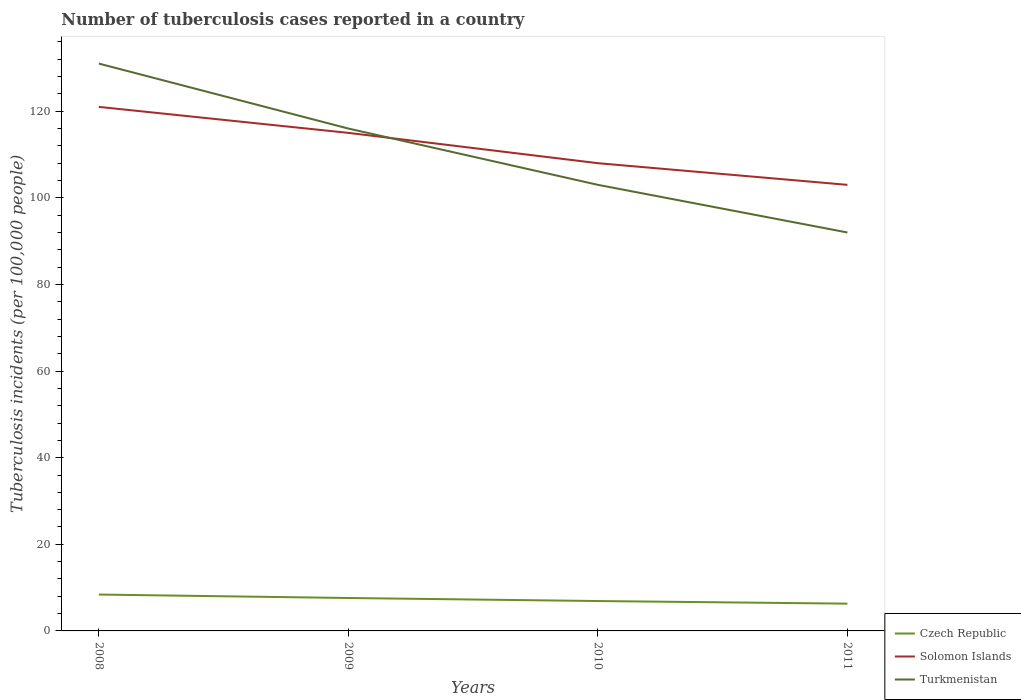How many different coloured lines are there?
Your answer should be very brief. 3. Does the line corresponding to Turkmenistan intersect with the line corresponding to Solomon Islands?
Ensure brevity in your answer.  Yes. Is the number of lines equal to the number of legend labels?
Keep it short and to the point. Yes. Across all years, what is the maximum number of tuberculosis cases reported in in Czech Republic?
Offer a very short reply. 6.3. What is the total number of tuberculosis cases reported in in Turkmenistan in the graph?
Your answer should be compact. 15. What is the difference between the highest and the second highest number of tuberculosis cases reported in in Solomon Islands?
Offer a very short reply. 18. What is the difference between the highest and the lowest number of tuberculosis cases reported in in Czech Republic?
Offer a terse response. 2. How many lines are there?
Give a very brief answer. 3. What is the difference between two consecutive major ticks on the Y-axis?
Offer a very short reply. 20. Are the values on the major ticks of Y-axis written in scientific E-notation?
Offer a terse response. No. Does the graph contain any zero values?
Give a very brief answer. No. Does the graph contain grids?
Provide a short and direct response. No. What is the title of the graph?
Keep it short and to the point. Number of tuberculosis cases reported in a country. What is the label or title of the X-axis?
Keep it short and to the point. Years. What is the label or title of the Y-axis?
Your response must be concise. Tuberculosis incidents (per 100,0 people). What is the Tuberculosis incidents (per 100,000 people) in Solomon Islands in 2008?
Give a very brief answer. 121. What is the Tuberculosis incidents (per 100,000 people) of Turkmenistan in 2008?
Your answer should be compact. 131. What is the Tuberculosis incidents (per 100,000 people) in Czech Republic in 2009?
Ensure brevity in your answer.  7.6. What is the Tuberculosis incidents (per 100,000 people) of Solomon Islands in 2009?
Your response must be concise. 115. What is the Tuberculosis incidents (per 100,000 people) in Turkmenistan in 2009?
Offer a very short reply. 116. What is the Tuberculosis incidents (per 100,000 people) of Czech Republic in 2010?
Your answer should be compact. 6.9. What is the Tuberculosis incidents (per 100,000 people) of Solomon Islands in 2010?
Offer a terse response. 108. What is the Tuberculosis incidents (per 100,000 people) in Turkmenistan in 2010?
Keep it short and to the point. 103. What is the Tuberculosis incidents (per 100,000 people) of Solomon Islands in 2011?
Make the answer very short. 103. What is the Tuberculosis incidents (per 100,000 people) of Turkmenistan in 2011?
Your answer should be compact. 92. Across all years, what is the maximum Tuberculosis incidents (per 100,000 people) in Solomon Islands?
Your answer should be compact. 121. Across all years, what is the maximum Tuberculosis incidents (per 100,000 people) of Turkmenistan?
Your answer should be compact. 131. Across all years, what is the minimum Tuberculosis incidents (per 100,000 people) of Czech Republic?
Offer a very short reply. 6.3. Across all years, what is the minimum Tuberculosis incidents (per 100,000 people) of Solomon Islands?
Give a very brief answer. 103. Across all years, what is the minimum Tuberculosis incidents (per 100,000 people) in Turkmenistan?
Ensure brevity in your answer.  92. What is the total Tuberculosis incidents (per 100,000 people) in Czech Republic in the graph?
Your response must be concise. 29.2. What is the total Tuberculosis incidents (per 100,000 people) in Solomon Islands in the graph?
Your answer should be compact. 447. What is the total Tuberculosis incidents (per 100,000 people) of Turkmenistan in the graph?
Your response must be concise. 442. What is the difference between the Tuberculosis incidents (per 100,000 people) in Solomon Islands in 2008 and that in 2009?
Keep it short and to the point. 6. What is the difference between the Tuberculosis incidents (per 100,000 people) of Czech Republic in 2008 and that in 2010?
Give a very brief answer. 1.5. What is the difference between the Tuberculosis incidents (per 100,000 people) in Solomon Islands in 2008 and that in 2011?
Your response must be concise. 18. What is the difference between the Tuberculosis incidents (per 100,000 people) of Turkmenistan in 2008 and that in 2011?
Provide a short and direct response. 39. What is the difference between the Tuberculosis incidents (per 100,000 people) in Solomon Islands in 2009 and that in 2010?
Your response must be concise. 7. What is the difference between the Tuberculosis incidents (per 100,000 people) in Turkmenistan in 2009 and that in 2010?
Keep it short and to the point. 13. What is the difference between the Tuberculosis incidents (per 100,000 people) of Turkmenistan in 2009 and that in 2011?
Make the answer very short. 24. What is the difference between the Tuberculosis incidents (per 100,000 people) in Czech Republic in 2008 and the Tuberculosis incidents (per 100,000 people) in Solomon Islands in 2009?
Keep it short and to the point. -106.6. What is the difference between the Tuberculosis incidents (per 100,000 people) of Czech Republic in 2008 and the Tuberculosis incidents (per 100,000 people) of Turkmenistan in 2009?
Make the answer very short. -107.6. What is the difference between the Tuberculosis incidents (per 100,000 people) of Solomon Islands in 2008 and the Tuberculosis incidents (per 100,000 people) of Turkmenistan in 2009?
Your response must be concise. 5. What is the difference between the Tuberculosis incidents (per 100,000 people) of Czech Republic in 2008 and the Tuberculosis incidents (per 100,000 people) of Solomon Islands in 2010?
Ensure brevity in your answer.  -99.6. What is the difference between the Tuberculosis incidents (per 100,000 people) of Czech Republic in 2008 and the Tuberculosis incidents (per 100,000 people) of Turkmenistan in 2010?
Your answer should be compact. -94.6. What is the difference between the Tuberculosis incidents (per 100,000 people) of Solomon Islands in 2008 and the Tuberculosis incidents (per 100,000 people) of Turkmenistan in 2010?
Your response must be concise. 18. What is the difference between the Tuberculosis incidents (per 100,000 people) in Czech Republic in 2008 and the Tuberculosis incidents (per 100,000 people) in Solomon Islands in 2011?
Your answer should be compact. -94.6. What is the difference between the Tuberculosis incidents (per 100,000 people) of Czech Republic in 2008 and the Tuberculosis incidents (per 100,000 people) of Turkmenistan in 2011?
Provide a short and direct response. -83.6. What is the difference between the Tuberculosis incidents (per 100,000 people) of Solomon Islands in 2008 and the Tuberculosis incidents (per 100,000 people) of Turkmenistan in 2011?
Keep it short and to the point. 29. What is the difference between the Tuberculosis incidents (per 100,000 people) of Czech Republic in 2009 and the Tuberculosis incidents (per 100,000 people) of Solomon Islands in 2010?
Offer a terse response. -100.4. What is the difference between the Tuberculosis incidents (per 100,000 people) in Czech Republic in 2009 and the Tuberculosis incidents (per 100,000 people) in Turkmenistan in 2010?
Keep it short and to the point. -95.4. What is the difference between the Tuberculosis incidents (per 100,000 people) in Solomon Islands in 2009 and the Tuberculosis incidents (per 100,000 people) in Turkmenistan in 2010?
Give a very brief answer. 12. What is the difference between the Tuberculosis incidents (per 100,000 people) of Czech Republic in 2009 and the Tuberculosis incidents (per 100,000 people) of Solomon Islands in 2011?
Ensure brevity in your answer.  -95.4. What is the difference between the Tuberculosis incidents (per 100,000 people) in Czech Republic in 2009 and the Tuberculosis incidents (per 100,000 people) in Turkmenistan in 2011?
Keep it short and to the point. -84.4. What is the difference between the Tuberculosis incidents (per 100,000 people) in Solomon Islands in 2009 and the Tuberculosis incidents (per 100,000 people) in Turkmenistan in 2011?
Give a very brief answer. 23. What is the difference between the Tuberculosis incidents (per 100,000 people) of Czech Republic in 2010 and the Tuberculosis incidents (per 100,000 people) of Solomon Islands in 2011?
Offer a terse response. -96.1. What is the difference between the Tuberculosis incidents (per 100,000 people) of Czech Republic in 2010 and the Tuberculosis incidents (per 100,000 people) of Turkmenistan in 2011?
Offer a very short reply. -85.1. What is the difference between the Tuberculosis incidents (per 100,000 people) of Solomon Islands in 2010 and the Tuberculosis incidents (per 100,000 people) of Turkmenistan in 2011?
Provide a short and direct response. 16. What is the average Tuberculosis incidents (per 100,000 people) in Czech Republic per year?
Offer a very short reply. 7.3. What is the average Tuberculosis incidents (per 100,000 people) in Solomon Islands per year?
Provide a succinct answer. 111.75. What is the average Tuberculosis incidents (per 100,000 people) of Turkmenistan per year?
Your answer should be compact. 110.5. In the year 2008, what is the difference between the Tuberculosis incidents (per 100,000 people) in Czech Republic and Tuberculosis incidents (per 100,000 people) in Solomon Islands?
Keep it short and to the point. -112.6. In the year 2008, what is the difference between the Tuberculosis incidents (per 100,000 people) in Czech Republic and Tuberculosis incidents (per 100,000 people) in Turkmenistan?
Keep it short and to the point. -122.6. In the year 2009, what is the difference between the Tuberculosis incidents (per 100,000 people) in Czech Republic and Tuberculosis incidents (per 100,000 people) in Solomon Islands?
Your response must be concise. -107.4. In the year 2009, what is the difference between the Tuberculosis incidents (per 100,000 people) of Czech Republic and Tuberculosis incidents (per 100,000 people) of Turkmenistan?
Provide a succinct answer. -108.4. In the year 2010, what is the difference between the Tuberculosis incidents (per 100,000 people) in Czech Republic and Tuberculosis incidents (per 100,000 people) in Solomon Islands?
Give a very brief answer. -101.1. In the year 2010, what is the difference between the Tuberculosis incidents (per 100,000 people) in Czech Republic and Tuberculosis incidents (per 100,000 people) in Turkmenistan?
Ensure brevity in your answer.  -96.1. In the year 2011, what is the difference between the Tuberculosis incidents (per 100,000 people) of Czech Republic and Tuberculosis incidents (per 100,000 people) of Solomon Islands?
Make the answer very short. -96.7. In the year 2011, what is the difference between the Tuberculosis incidents (per 100,000 people) in Czech Republic and Tuberculosis incidents (per 100,000 people) in Turkmenistan?
Make the answer very short. -85.7. In the year 2011, what is the difference between the Tuberculosis incidents (per 100,000 people) of Solomon Islands and Tuberculosis incidents (per 100,000 people) of Turkmenistan?
Your response must be concise. 11. What is the ratio of the Tuberculosis incidents (per 100,000 people) of Czech Republic in 2008 to that in 2009?
Keep it short and to the point. 1.11. What is the ratio of the Tuberculosis incidents (per 100,000 people) in Solomon Islands in 2008 to that in 2009?
Provide a short and direct response. 1.05. What is the ratio of the Tuberculosis incidents (per 100,000 people) of Turkmenistan in 2008 to that in 2009?
Provide a succinct answer. 1.13. What is the ratio of the Tuberculosis incidents (per 100,000 people) in Czech Republic in 2008 to that in 2010?
Make the answer very short. 1.22. What is the ratio of the Tuberculosis incidents (per 100,000 people) in Solomon Islands in 2008 to that in 2010?
Your answer should be compact. 1.12. What is the ratio of the Tuberculosis incidents (per 100,000 people) of Turkmenistan in 2008 to that in 2010?
Keep it short and to the point. 1.27. What is the ratio of the Tuberculosis incidents (per 100,000 people) of Solomon Islands in 2008 to that in 2011?
Provide a succinct answer. 1.17. What is the ratio of the Tuberculosis incidents (per 100,000 people) in Turkmenistan in 2008 to that in 2011?
Your answer should be very brief. 1.42. What is the ratio of the Tuberculosis incidents (per 100,000 people) in Czech Republic in 2009 to that in 2010?
Your answer should be very brief. 1.1. What is the ratio of the Tuberculosis incidents (per 100,000 people) in Solomon Islands in 2009 to that in 2010?
Offer a very short reply. 1.06. What is the ratio of the Tuberculosis incidents (per 100,000 people) of Turkmenistan in 2009 to that in 2010?
Your response must be concise. 1.13. What is the ratio of the Tuberculosis incidents (per 100,000 people) in Czech Republic in 2009 to that in 2011?
Offer a terse response. 1.21. What is the ratio of the Tuberculosis incidents (per 100,000 people) in Solomon Islands in 2009 to that in 2011?
Provide a succinct answer. 1.12. What is the ratio of the Tuberculosis incidents (per 100,000 people) in Turkmenistan in 2009 to that in 2011?
Provide a succinct answer. 1.26. What is the ratio of the Tuberculosis incidents (per 100,000 people) in Czech Republic in 2010 to that in 2011?
Make the answer very short. 1.1. What is the ratio of the Tuberculosis incidents (per 100,000 people) of Solomon Islands in 2010 to that in 2011?
Provide a succinct answer. 1.05. What is the ratio of the Tuberculosis incidents (per 100,000 people) of Turkmenistan in 2010 to that in 2011?
Make the answer very short. 1.12. What is the difference between the highest and the second highest Tuberculosis incidents (per 100,000 people) in Solomon Islands?
Your response must be concise. 6. What is the difference between the highest and the second highest Tuberculosis incidents (per 100,000 people) of Turkmenistan?
Make the answer very short. 15. What is the difference between the highest and the lowest Tuberculosis incidents (per 100,000 people) of Turkmenistan?
Offer a very short reply. 39. 